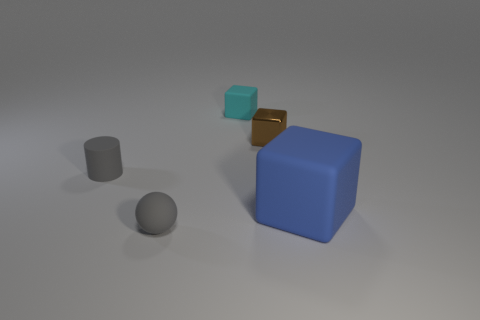Subtract all blue cubes. How many cubes are left? 2 Subtract all small blocks. How many blocks are left? 1 Add 5 metallic blocks. How many objects exist? 10 Subtract all spheres. How many objects are left? 4 Subtract all blue rubber cubes. Subtract all tiny gray rubber cylinders. How many objects are left? 3 Add 1 matte things. How many matte things are left? 5 Add 3 big gray rubber cylinders. How many big gray rubber cylinders exist? 3 Subtract 0 brown spheres. How many objects are left? 5 Subtract 1 cylinders. How many cylinders are left? 0 Subtract all purple cylinders. Subtract all cyan balls. How many cylinders are left? 1 